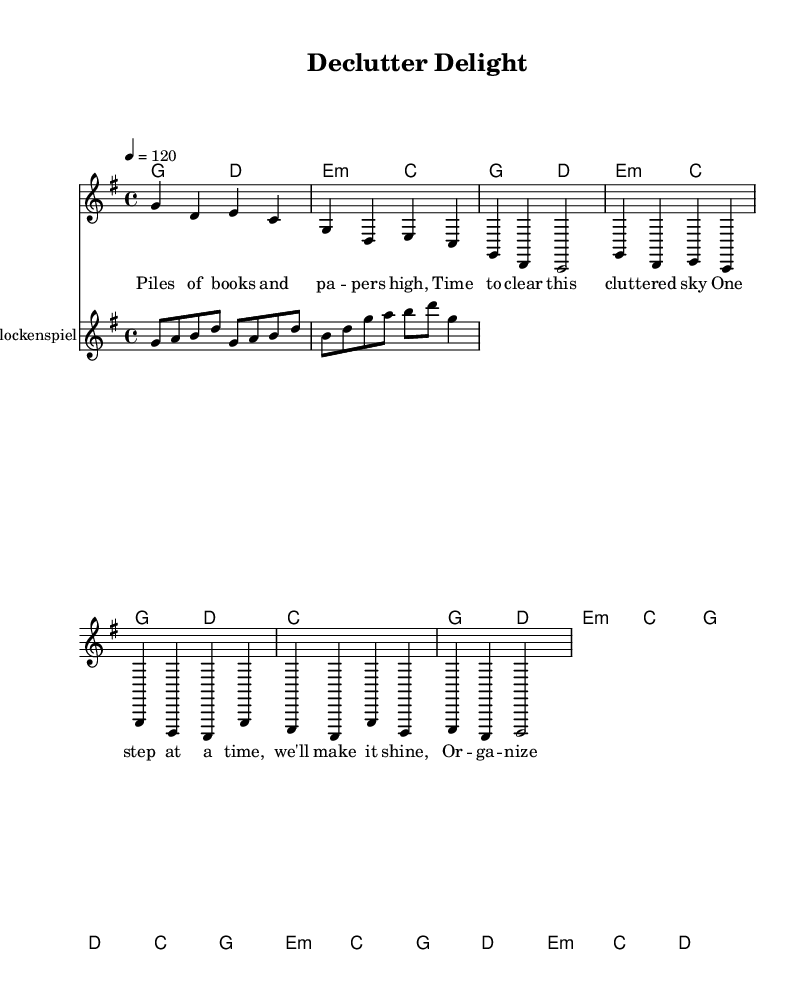What is the key signature of this music? The key signature is indicated at the beginning of the piece, showing one sharp, which corresponds to G major.
Answer: G major What is the time signature? The time signature is shown at the beginning of the music, represented as 4/4, meaning there are four beats in each measure.
Answer: 4/4 What is the tempo marking? The tempo is indicated as 4 = 120, which tells us to play the quarter note at a speed of 120 beats per minute.
Answer: 120 How many measures are in the chorus section? By counting the measures in the chorus part of the score, we find that there are four measures.
Answer: 4 What is the instrument used for the melody? The main voice in the score, labeled as "lead," represents the melody, which is played by a standard instrument (typically a piano or guitar).
Answer: Lead What does the lyric "One step at a time, we'll make it shine" represent in the structure of the music? This lyric is part of the chorus section of the song, distinguishing it from the verse lyrics and illustrating the central message of the piece.
Answer: Chorus What type of accompaniment is provided in this sheet music? The harmonies written under the melody line represent chord progressions typical of accompaniment in pop and indie soundtracks.
Answer: Chord progression 